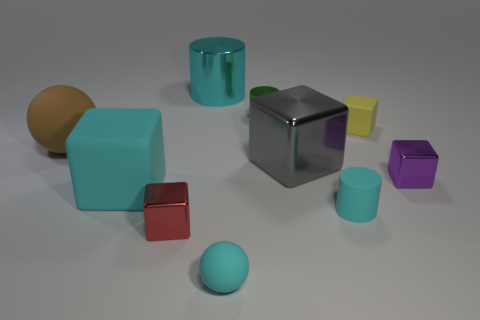Subtract all cylinders. How many objects are left? 7 Subtract all cyan matte cylinders. Subtract all cyan matte cylinders. How many objects are left? 8 Add 8 small cyan things. How many small cyan things are left? 10 Add 2 purple cubes. How many purple cubes exist? 3 Subtract 0 purple spheres. How many objects are left? 10 